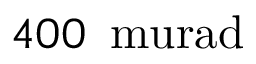<formula> <loc_0><loc_0><loc_500><loc_500>4 0 0 \, \ m u r a d</formula> 